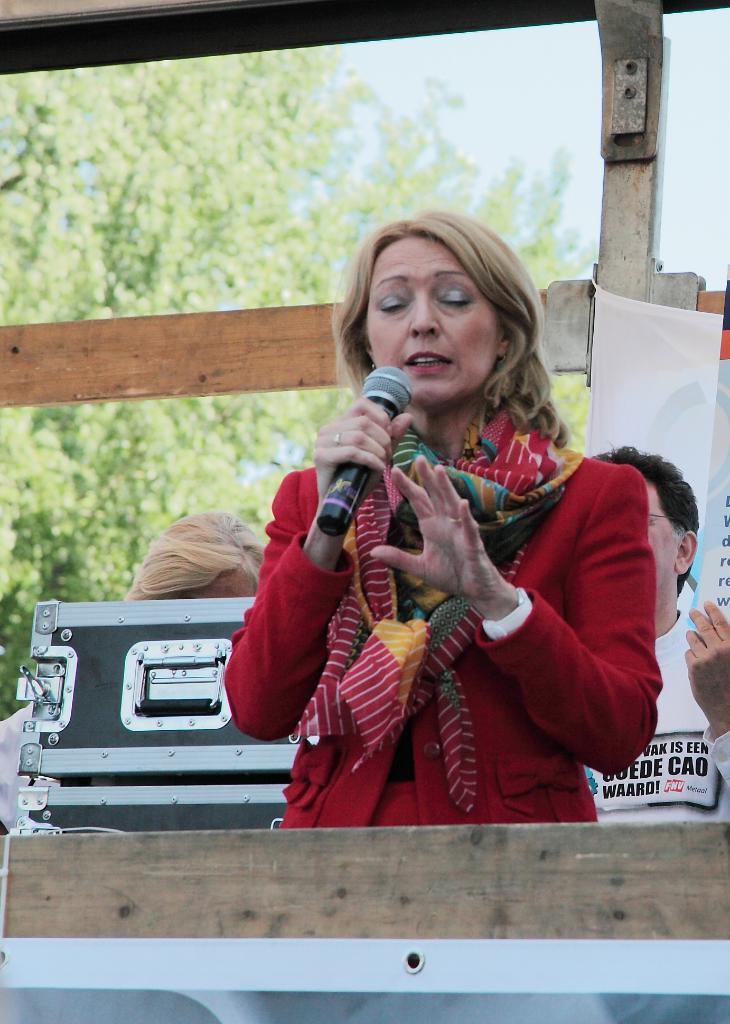How would you summarize this image in a sentence or two? In this given picture, I can see women standing and holding a mike and behind a person, I can see a person sitting towards left, We can see a women with light brown color hair and top i can see a wooden piece of wood, few trees, musical boxes a tool boxes. 